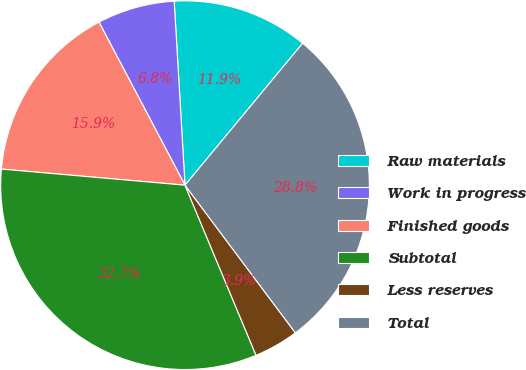Convert chart. <chart><loc_0><loc_0><loc_500><loc_500><pie_chart><fcel>Raw materials<fcel>Work in progress<fcel>Finished goods<fcel>Subtotal<fcel>Less reserves<fcel>Total<nl><fcel>11.95%<fcel>6.79%<fcel>15.88%<fcel>32.69%<fcel>3.92%<fcel>28.77%<nl></chart> 